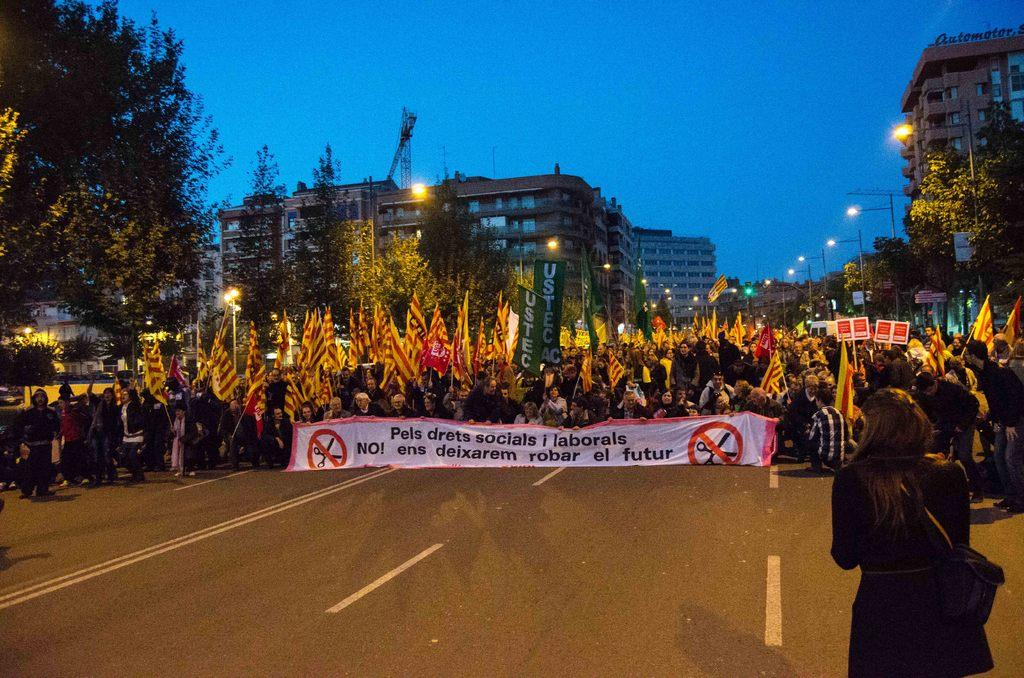What are the people in the image holding? The people in the image are holding flags, banners, and boards. What might the flags, banners, and boards represent? The flags, banners, and boards might represent a cause, event, or organization. What can be seen in the background of the image? In the background of the image, there are buildings, light poles, and trees. What is the color of the sky in the image? The sky is blue in color. Where is the bucket located in the image? There is no bucket present in the image. What type of brick is being used to build the buildings in the background? There is no information about the type of brick used to build the buildings in the image. 